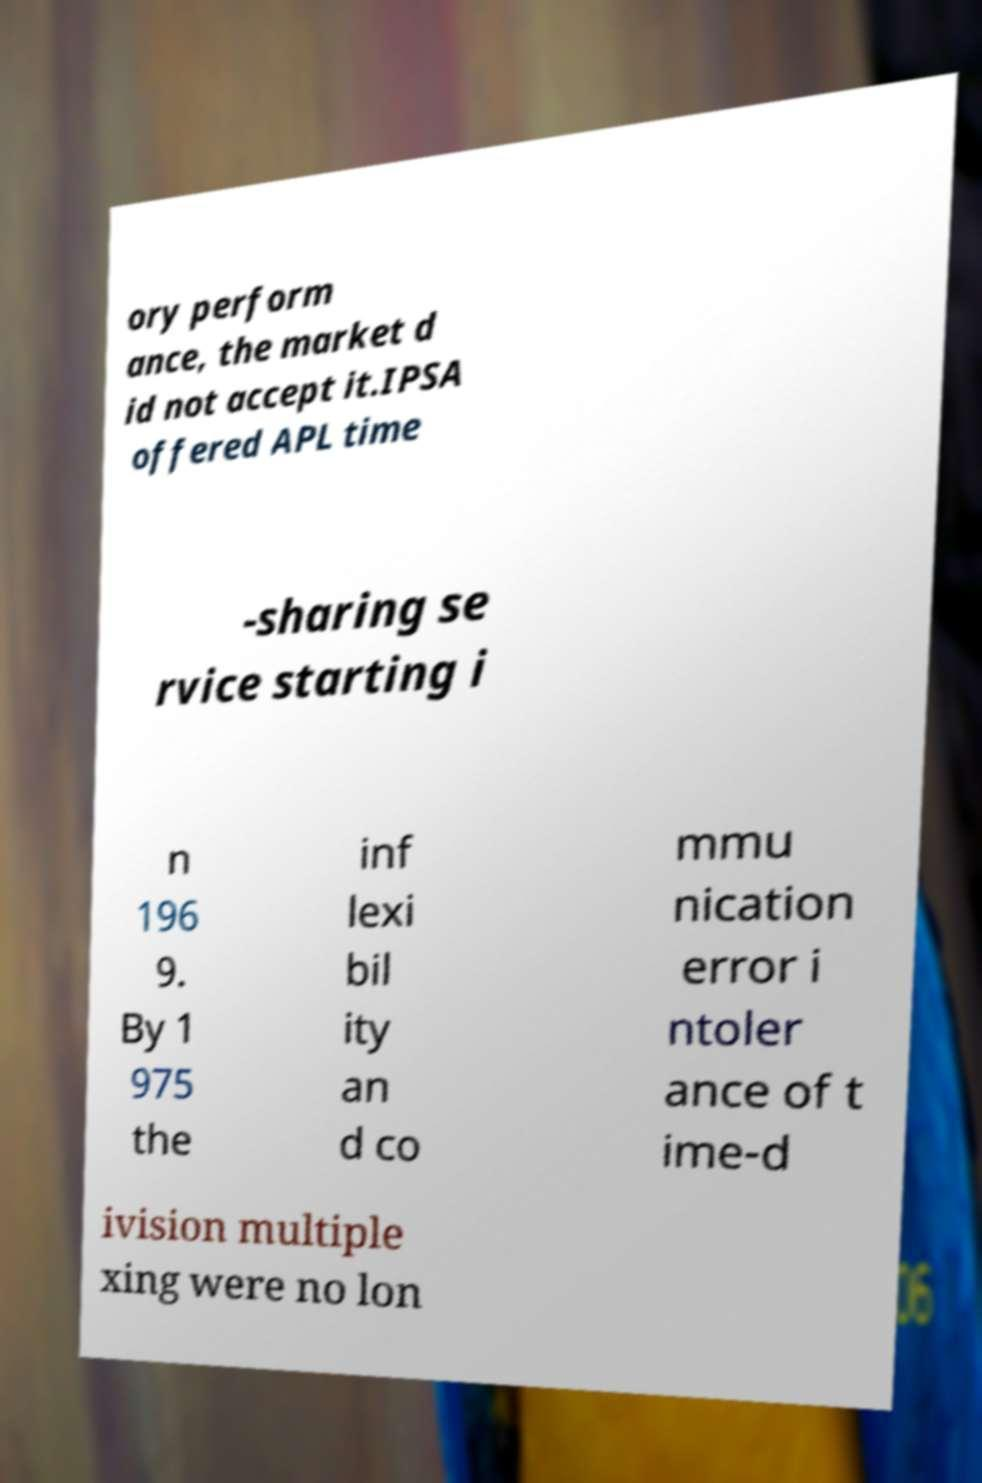Can you accurately transcribe the text from the provided image for me? ory perform ance, the market d id not accept it.IPSA offered APL time -sharing se rvice starting i n 196 9. By 1 975 the inf lexi bil ity an d co mmu nication error i ntoler ance of t ime-d ivision multiple xing were no lon 